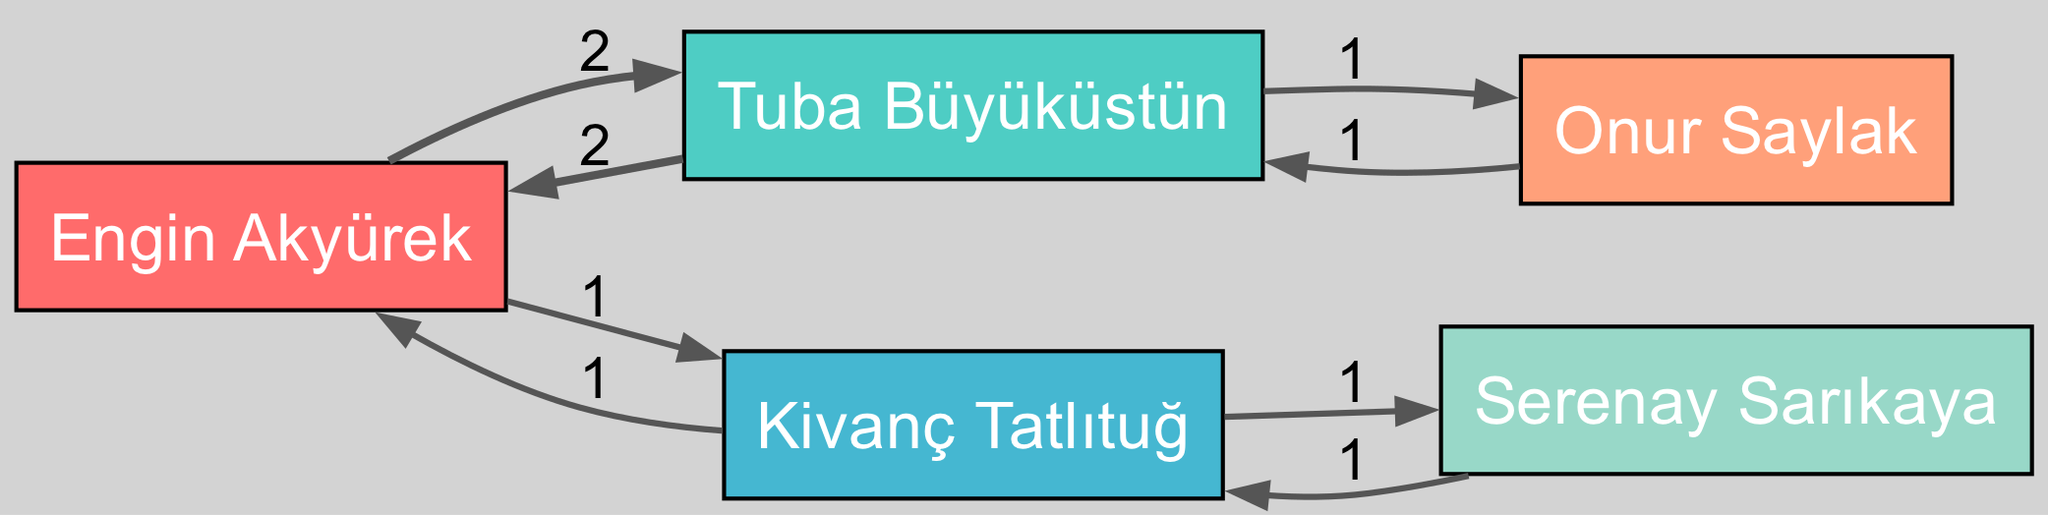What actors have worked the most projects together? To find the actors with the most projects together, I need to examine the edges in the diagram which represent co-starring relationships. Engin Akyürek and Tuba Büyüküstün have the highest connection with 2 projects.
Answer: Engin Akyürek, Tuba Büyüküstün How many actors are in the diagram? The number of actors can be determined by counting the nodes present in the diagram. There are 5 nodes representing actors: Engin Akyürek, Tuba Büyüküstün, Kivanç Tatlıtuğ, Onur Saylak, and Serenay Sarıkaya.
Answer: 5 Which actor co-starred with Onur Saylak? By looking at the edges connected to Onur Saylak, it is clear that the only other actor he co-starred with is Tuba Büyüküstün.
Answer: Tuba Büyüküstün How many total projects does Kivanç Tatlıtuğ have with other actors? Kivanç Tatlıtuğ has worked on 1 project with Engin Akyürek and 1 project with Serenay Sarıkaya. By summing these numbers, the total projects is 1 + 1 = 2.
Answer: 2 Which actor is the only co-star of Serenay Sarıkaya? To find the only co-star of Serenay Sarıkaya, I check the edges leading from her node. The only connection is to Kivanç Tatlıtuğ.
Answer: Kivanç Tatlıtuğ How many edges are connected to Engin Akyürek? To determine the number of edges connected to Engin Akyürek, I review the co-stars listed. He has edges connecting to Tuba Büyüküstün (2 projects) and Kivanç Tatlıtuğ (1 project), totaling 2 edges.
Answer: 2 